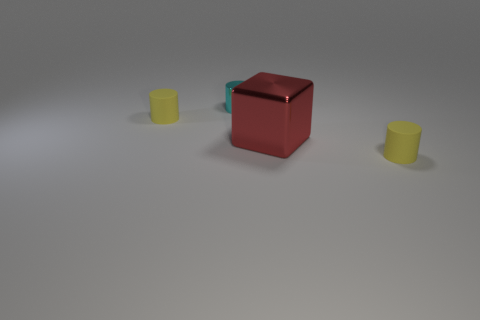Does the yellow cylinder that is right of the tiny cyan shiny object have the same material as the red cube?
Your response must be concise. No. How many objects are the same color as the metal cylinder?
Make the answer very short. 0. Is the number of small cyan metallic things that are on the left side of the small cyan object less than the number of small matte cylinders in front of the red metallic object?
Offer a terse response. Yes. Are there any objects to the left of the red cube?
Provide a short and direct response. Yes. There is a small yellow thing that is left of the tiny yellow cylinder right of the tiny cyan metal object; is there a small yellow matte cylinder that is right of it?
Give a very brief answer. Yes. There is a tiny thing in front of the red metal block; is it the same shape as the red thing?
Provide a short and direct response. No. What color is the cylinder that is made of the same material as the red cube?
Offer a very short reply. Cyan. How many big blocks are made of the same material as the red thing?
Provide a succinct answer. 0. There is a small object behind the rubber cylinder that is to the left of the yellow rubber cylinder right of the cube; what color is it?
Offer a very short reply. Cyan. Is there anything else that is the same shape as the small shiny thing?
Keep it short and to the point. Yes. 